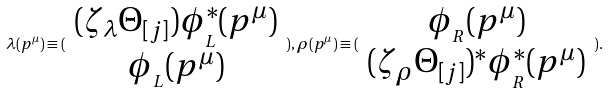Convert formula to latex. <formula><loc_0><loc_0><loc_500><loc_500>\lambda ( p ^ { \mu } ) \equiv ( \begin{array} { c } ( \zeta _ { \lambda } \Theta _ { [ j ] } ) \phi _ { _ { L } } ^ { \ast } ( p ^ { \mu } ) \\ \phi _ { _ { L } } ( p ^ { \mu } ) \end{array} ) , \rho ( p ^ { \mu } ) \equiv ( \begin{array} { c } \phi _ { _ { R } } ( p ^ { \mu } ) \\ ( \zeta _ { \rho } \Theta _ { [ j ] } ) ^ { \ast } \phi _ { _ { R } } ^ { \ast } ( p ^ { \mu } ) \end{array} ) .</formula> 